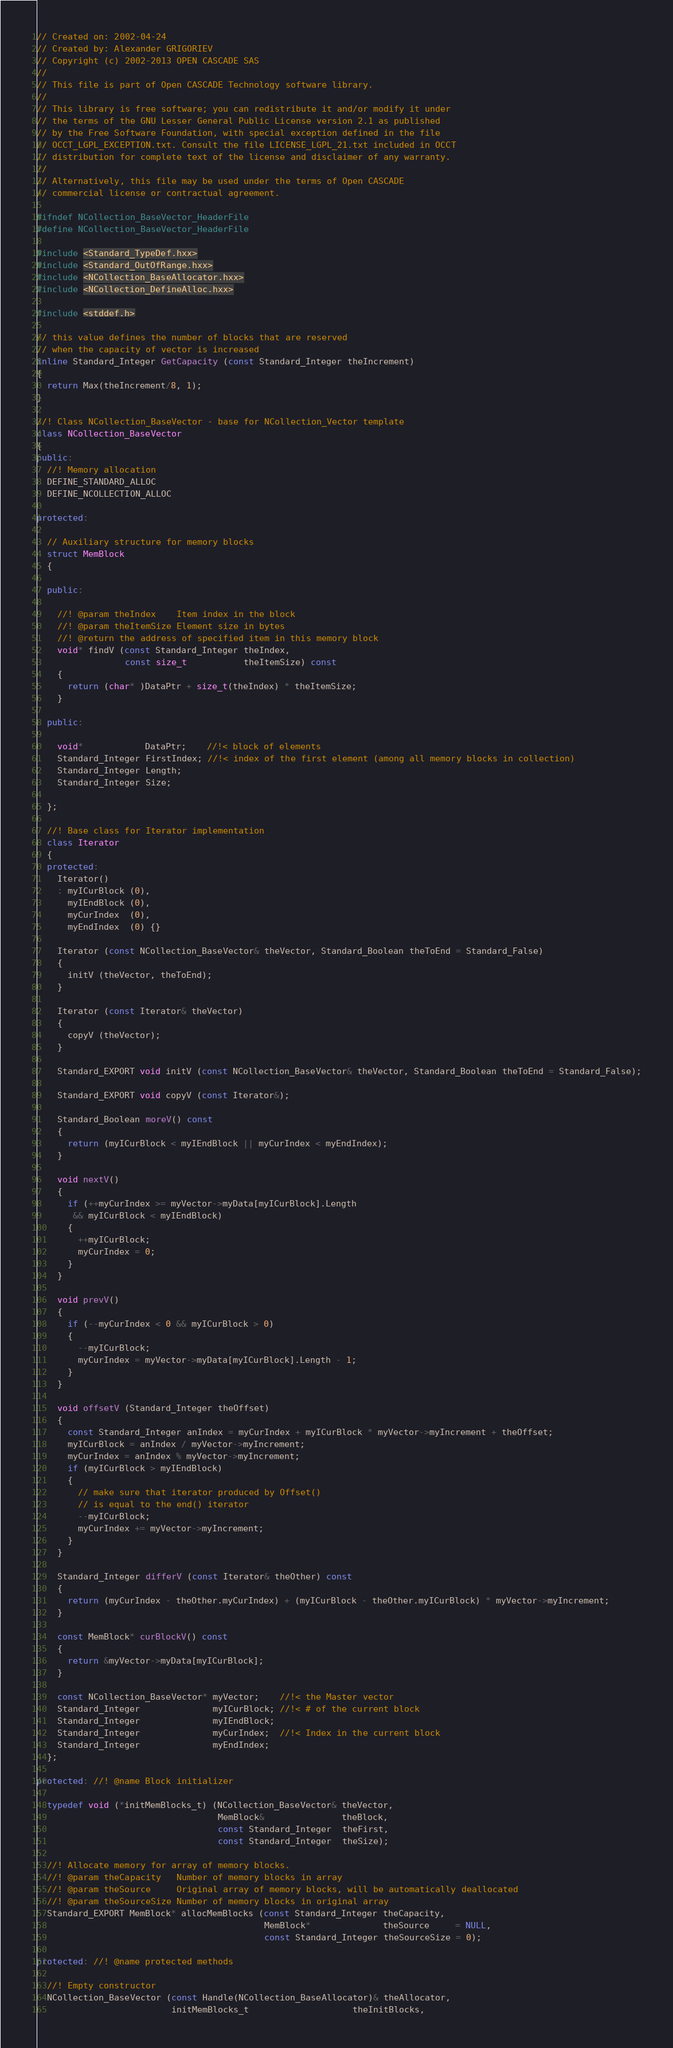<code> <loc_0><loc_0><loc_500><loc_500><_C++_>// Created on: 2002-04-24
// Created by: Alexander GRIGORIEV
// Copyright (c) 2002-2013 OPEN CASCADE SAS
//
// This file is part of Open CASCADE Technology software library.
//
// This library is free software; you can redistribute it and/or modify it under
// the terms of the GNU Lesser General Public License version 2.1 as published
// by the Free Software Foundation, with special exception defined in the file
// OCCT_LGPL_EXCEPTION.txt. Consult the file LICENSE_LGPL_21.txt included in OCCT
// distribution for complete text of the license and disclaimer of any warranty.
//
// Alternatively, this file may be used under the terms of Open CASCADE
// commercial license or contractual agreement.

#ifndef NCollection_BaseVector_HeaderFile
#define NCollection_BaseVector_HeaderFile

#include <Standard_TypeDef.hxx>
#include <Standard_OutOfRange.hxx>
#include <NCollection_BaseAllocator.hxx>
#include <NCollection_DefineAlloc.hxx>

#include <stddef.h>

// this value defines the number of blocks that are reserved
// when the capacity of vector is increased
inline Standard_Integer GetCapacity (const Standard_Integer theIncrement)
{
  return Max(theIncrement/8, 1);
}

//! Class NCollection_BaseVector - base for NCollection_Vector template
class NCollection_BaseVector
{
public:
  //! Memory allocation
  DEFINE_STANDARD_ALLOC
  DEFINE_NCOLLECTION_ALLOC

protected:

  // Auxiliary structure for memory blocks
  struct MemBlock
  {

  public:

    //! @param theIndex    Item index in the block
    //! @param theItemSize Element size in bytes
    //! @return the address of specified item in this memory block
    void* findV (const Standard_Integer theIndex,
                 const size_t           theItemSize) const
    {
      return (char* )DataPtr + size_t(theIndex) * theItemSize;
    }

  public:

    void*            DataPtr;    //!< block of elements
    Standard_Integer FirstIndex; //!< index of the first element (among all memory blocks in collection)
    Standard_Integer Length;
    Standard_Integer Size;

  };

  //! Base class for Iterator implementation
  class Iterator
  {
  protected:
    Iterator()
    : myICurBlock (0),
      myIEndBlock (0),
      myCurIndex  (0),
      myEndIndex  (0) {}

    Iterator (const NCollection_BaseVector& theVector, Standard_Boolean theToEnd = Standard_False)
    {
      initV (theVector, theToEnd);
    }

    Iterator (const Iterator& theVector)
    {
      copyV (theVector);
    }

    Standard_EXPORT void initV (const NCollection_BaseVector& theVector, Standard_Boolean theToEnd = Standard_False);

    Standard_EXPORT void copyV (const Iterator&);

    Standard_Boolean moreV() const
    {
      return (myICurBlock < myIEndBlock || myCurIndex < myEndIndex);
    }

    void nextV()
    {
      if (++myCurIndex >= myVector->myData[myICurBlock].Length
       && myICurBlock < myIEndBlock)
      {
        ++myICurBlock;
        myCurIndex = 0;
      }
    }

    void prevV()
    {
      if (--myCurIndex < 0 && myICurBlock > 0)
      {
        --myICurBlock;
        myCurIndex = myVector->myData[myICurBlock].Length - 1;
      }
    }

    void offsetV (Standard_Integer theOffset)
    {
      const Standard_Integer anIndex = myCurIndex + myICurBlock * myVector->myIncrement + theOffset;
      myICurBlock = anIndex / myVector->myIncrement;
      myCurIndex = anIndex % myVector->myIncrement;
      if (myICurBlock > myIEndBlock)
      {
        // make sure that iterator produced by Offset()
        // is equal to the end() iterator
        --myICurBlock;
        myCurIndex += myVector->myIncrement;
      }
    }

    Standard_Integer differV (const Iterator& theOther) const
    {
      return (myCurIndex - theOther.myCurIndex) + (myICurBlock - theOther.myICurBlock) * myVector->myIncrement;
    }

    const MemBlock* curBlockV() const
    {
      return &myVector->myData[myICurBlock];
    }

    const NCollection_BaseVector* myVector;    //!< the Master vector
    Standard_Integer              myICurBlock; //!< # of the current block
    Standard_Integer              myIEndBlock;
    Standard_Integer              myCurIndex;  //!< Index in the current block
    Standard_Integer              myEndIndex;
  };

protected: //! @name Block initializer

  typedef void (*initMemBlocks_t) (NCollection_BaseVector& theVector,
                                   MemBlock&               theBlock,
                                   const Standard_Integer  theFirst,
                                   const Standard_Integer  theSize);

  //! Allocate memory for array of memory blocks.
  //! @param theCapacity   Number of memory blocks in array
  //! @param theSource     Original array of memory blocks, will be automatically deallocated
  //! @param theSourceSize Number of memory blocks in original array
  Standard_EXPORT MemBlock* allocMemBlocks (const Standard_Integer theCapacity,
                                            MemBlock*              theSource     = NULL,
                                            const Standard_Integer theSourceSize = 0);

protected: //! @name protected methods

  //! Empty constructor
  NCollection_BaseVector (const Handle(NCollection_BaseAllocator)& theAllocator,
                          initMemBlocks_t                    theInitBlocks,</code> 